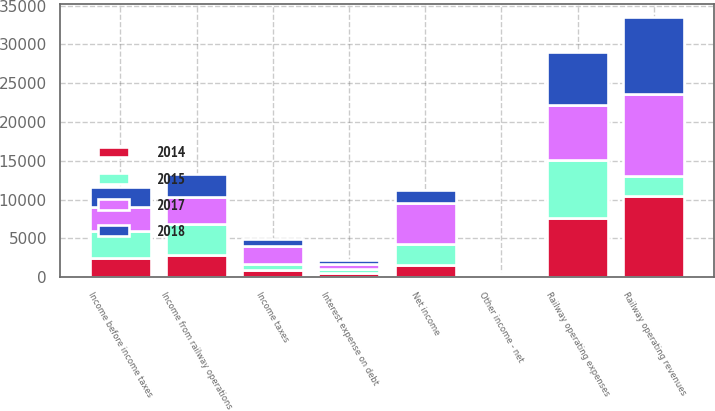<chart> <loc_0><loc_0><loc_500><loc_500><stacked_bar_chart><ecel><fcel>Railway operating revenues<fcel>Railway operating expenses<fcel>Income from railway operations<fcel>Other income - net<fcel>Interest expense on debt<fcel>Income before income taxes<fcel>Income taxes<fcel>Net income<nl><fcel>2015<fcel>2582<fcel>7499<fcel>3959<fcel>67<fcel>557<fcel>3469<fcel>803<fcel>2666<nl><fcel>2017<fcel>10551<fcel>7029<fcel>3522<fcel>156<fcel>550<fcel>3128<fcel>2276<fcel>5404<nl><fcel>2018<fcel>9888<fcel>6879<fcel>3009<fcel>136<fcel>563<fcel>2582<fcel>914<fcel>1668<nl><fcel>2014<fcel>10511<fcel>7656<fcel>2855<fcel>132<fcel>545<fcel>2442<fcel>886<fcel>1556<nl></chart> 